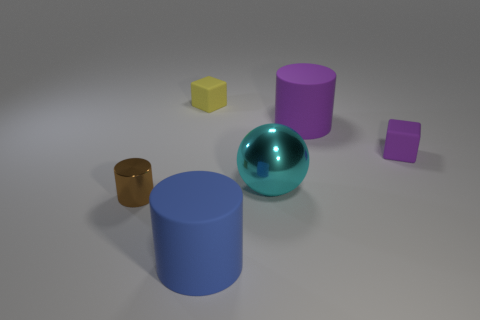What number of other rubber cylinders are the same size as the purple cylinder?
Your response must be concise. 1. Are there an equal number of small metallic things to the left of the small purple thing and small cylinders?
Offer a very short reply. Yes. What number of cylinders are both on the right side of the yellow rubber cube and in front of the cyan object?
Give a very brief answer. 1. What is the size of the yellow thing that is the same material as the purple cube?
Give a very brief answer. Small. What number of brown metallic things have the same shape as the large blue rubber thing?
Your response must be concise. 1. Are there more tiny brown metal things left of the blue rubber thing than big brown metallic cubes?
Provide a succinct answer. Yes. The matte thing that is both in front of the big purple cylinder and to the left of the large purple cylinder has what shape?
Offer a terse response. Cylinder. Does the metal cylinder have the same size as the cyan shiny sphere?
Your answer should be very brief. No. How many matte objects are in front of the brown shiny cylinder?
Make the answer very short. 1. Are there the same number of small matte objects to the right of the sphere and big metallic spheres in front of the big blue cylinder?
Offer a terse response. No. 